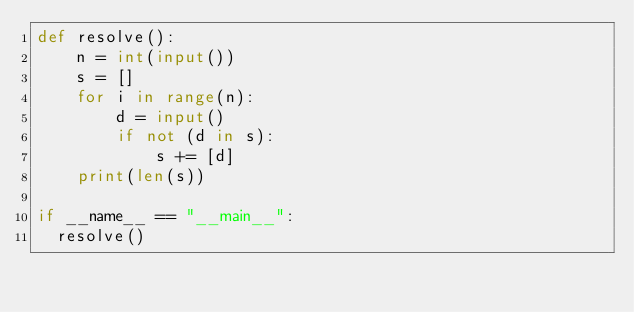<code> <loc_0><loc_0><loc_500><loc_500><_Python_>def resolve():
    n = int(input())
    s = []
    for i in range(n):
        d = input()
        if not (d in s):
            s += [d]
    print(len(s))

if __name__ == "__main__":
	resolve()</code> 